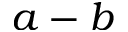<formula> <loc_0><loc_0><loc_500><loc_500>a - b</formula> 